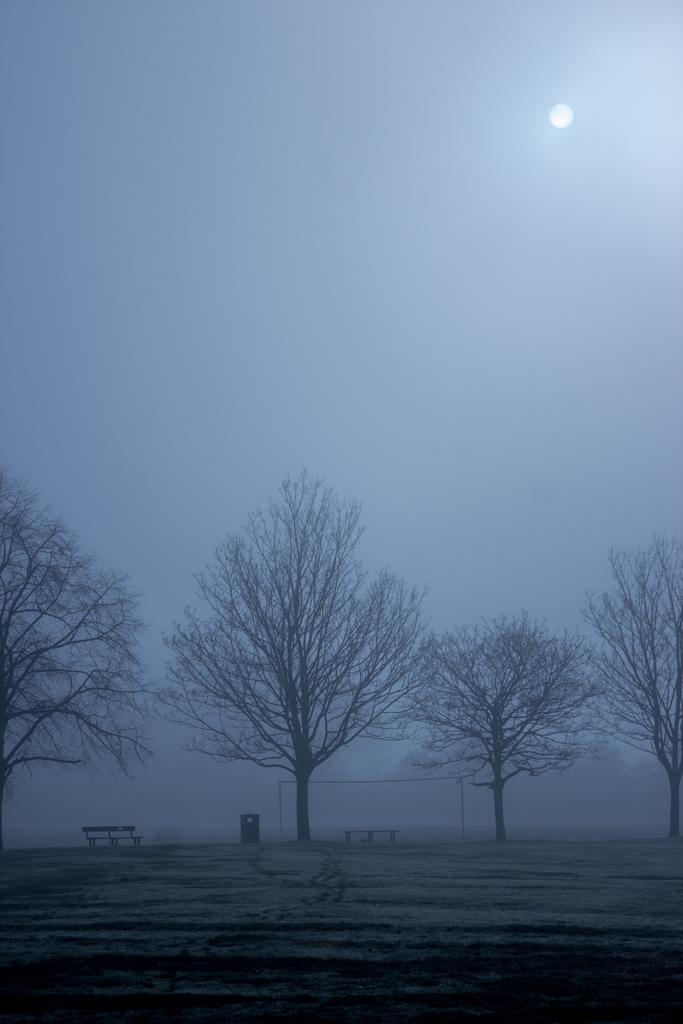What type of vegetation can be seen in the image? There are trees in the image. What type of seating is available in the image? There are benches in the image. What object is present for playing a game or sport? There is a net visible in the image. What celestial body is visible in the image? The moon is visible in the image, and it is white. What is the color of the sky in the image? The sky is blue in the image. Can you hear the ear in the image? There is no ear present in the image, so it cannot be heard. What game is being played in the image? The image does not depict a game being played; it only shows trees, benches, a net, the moon, and the blue sky. 